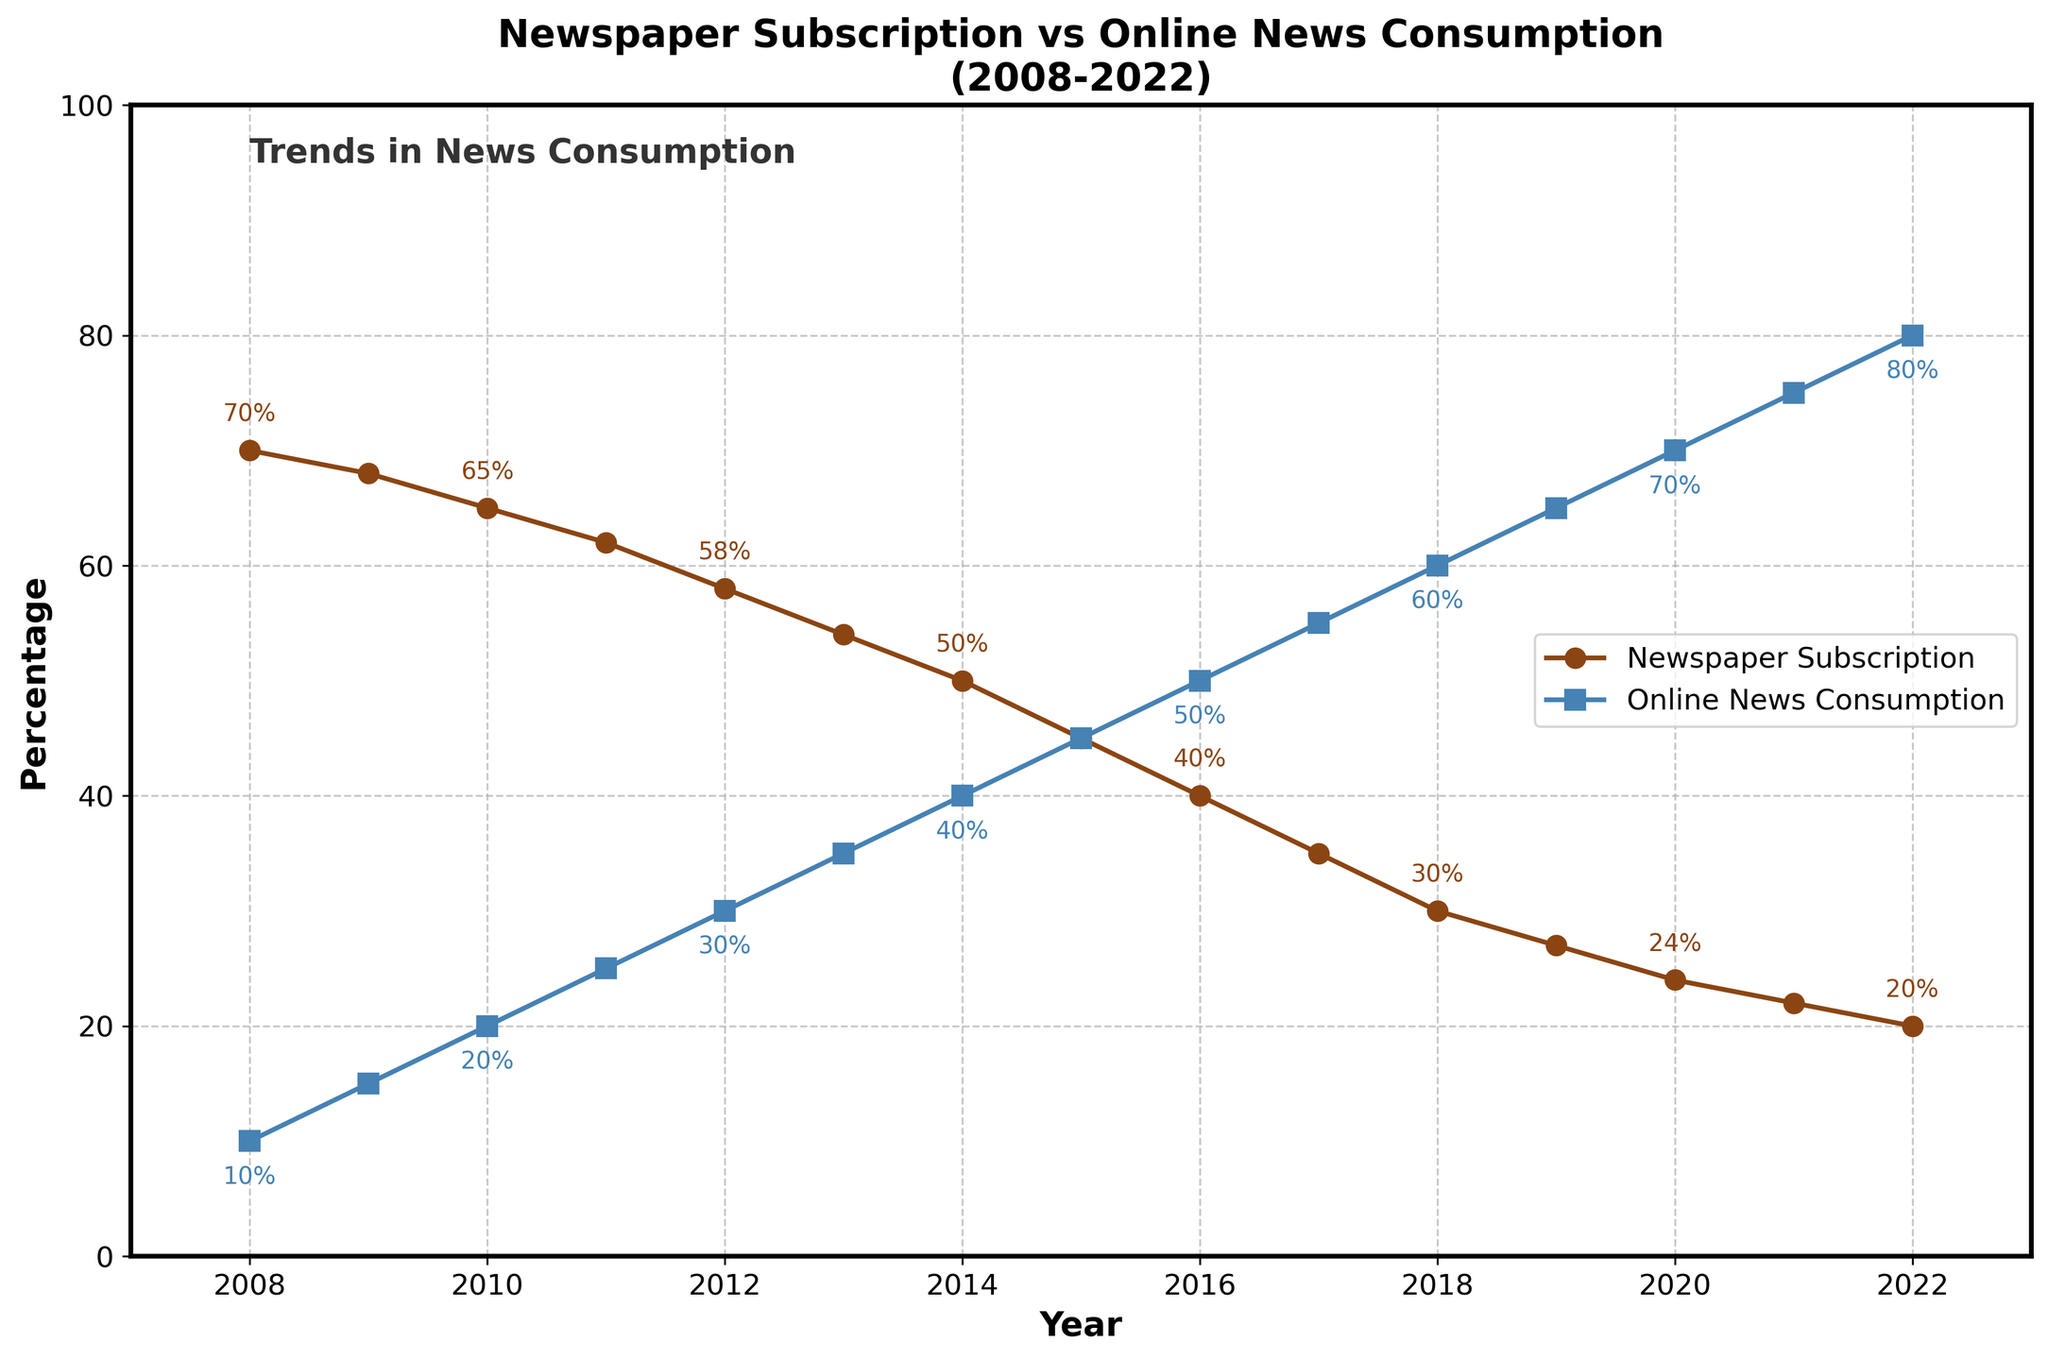What's the title of the chart? The title is usually at the top of the chart and provides a summary of what the chart represents. In this case, the title is located above the plot area.
Answer: Newspaper Subscription vs Online News Consumption (2008-2022) What is the x-axis representing? The x-axis is labeled as "Year," which means it represents the years from 2008 to 2022.
Answer: Year What color represents Online News Consumption in the plot? The Online News Consumption line is drawn using a specific color. In this plot, it is represented in a shade of blue.
Answer: Blue Which year had the lowest Newspaper Subscription Rates? To determine this, one must look at the plot and find the lowest point on the Newspaper Subscription Rates line (brown). This point occurs at the year labeled on the x-axis.
Answer: 2022 How much did the Newspaper Subscription Rates decrease from 2008 to 2022? By subtracting the Newspaper Subscription Rate in 2022 (20) from the rate in 2008 (70): 70 - 20 = 50. Therefore, the decrease is 50%.
Answer: 50% In which year did Online News Consumption surpass Newspaper Subscription Rates? To answer this, identify the year where the blue line (Online News Consumption) crosses above the brown line (Newspaper Subscription Rates). This crossing occurs at 2014.
Answer: 2014 What trend can be observed for Newspaper Subscription Rates over the years? Observing the brown line over time shows a continual downward trend, indicating a consistent decline in Newspaper Subscription Rates.
Answer: Continuous decline Compare Online News Consumption levels between 2008 and 2022. How much did it change? The Online News Consumption was 10% in 2008 and increased to 80% in 2022. To find the change, subtract the 2008 value from the 2022 value: 80% - 10% = 70%.
Answer: 70% What is the percentage difference between Newspaper Subscription Rates and Online News Consumption in 2022? Newspaper Subscription Rates are 20% in 2022, while Online News Consumption is 80%. The difference is calculated as 80% - 20% = 60%.
Answer: 60% What was the Online News Consumption rate in 2015? Locate the specific year (2015) on the x-axis, then find the corresponding value on the blue line. The rate shown is 45%.
Answer: 45% 